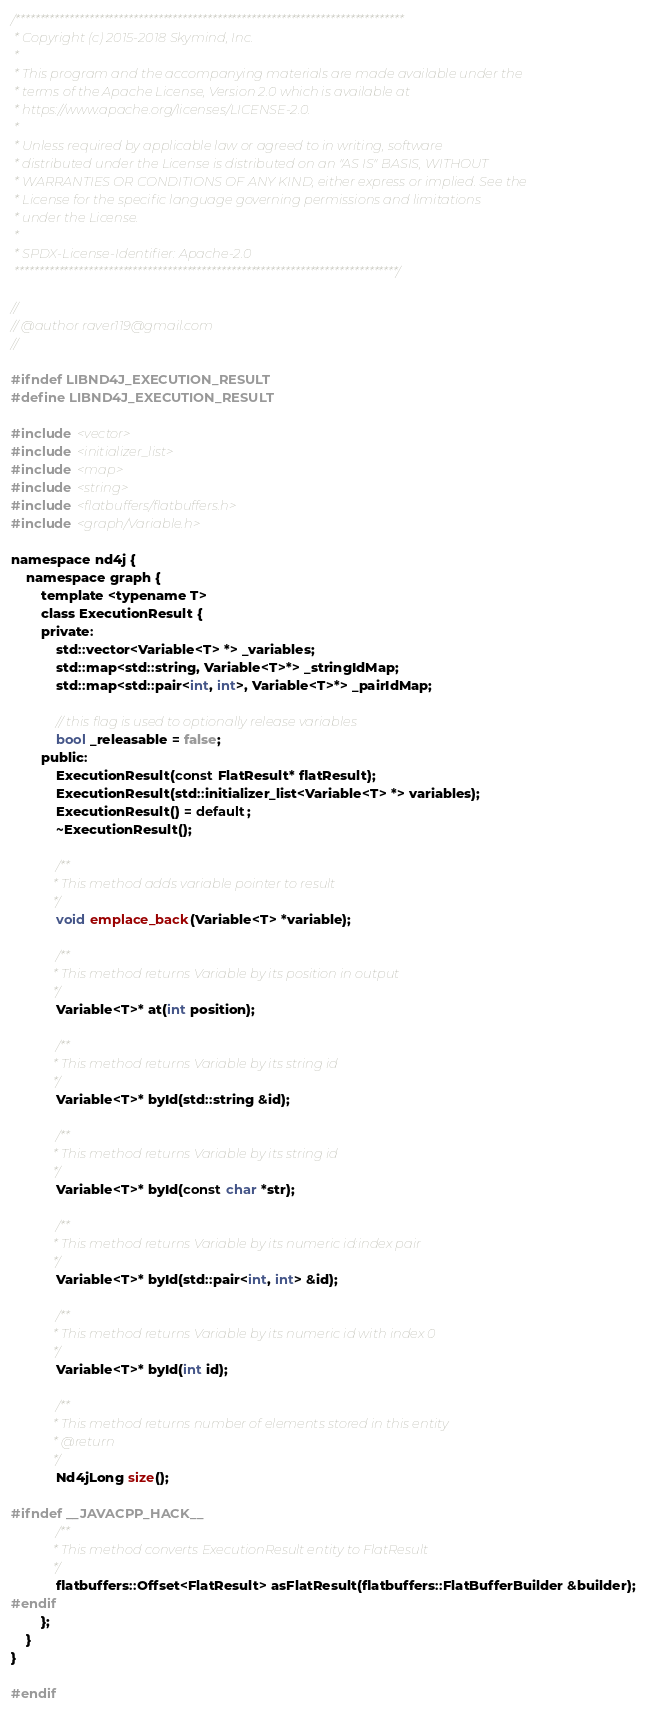<code> <loc_0><loc_0><loc_500><loc_500><_C_>/*******************************************************************************
 * Copyright (c) 2015-2018 Skymind, Inc.
 *
 * This program and the accompanying materials are made available under the
 * terms of the Apache License, Version 2.0 which is available at
 * https://www.apache.org/licenses/LICENSE-2.0.
 *
 * Unless required by applicable law or agreed to in writing, software
 * distributed under the License is distributed on an "AS IS" BASIS, WITHOUT
 * WARRANTIES OR CONDITIONS OF ANY KIND, either express or implied. See the
 * License for the specific language governing permissions and limitations
 * under the License.
 *
 * SPDX-License-Identifier: Apache-2.0
 ******************************************************************************/

//
// @author raver119@gmail.com
//

#ifndef LIBND4J_EXECUTION_RESULT
#define LIBND4J_EXECUTION_RESULT

#include <vector>
#include <initializer_list>
#include <map>
#include <string>
#include <flatbuffers/flatbuffers.h>
#include <graph/Variable.h>

namespace nd4j {
    namespace graph {
        template <typename T>
        class ExecutionResult {
        private:
            std::vector<Variable<T> *> _variables;
            std::map<std::string, Variable<T>*> _stringIdMap;
            std::map<std::pair<int, int>, Variable<T>*> _pairIdMap;

            // this flag is used to optionally release variables
            bool _releasable = false;
        public:
            ExecutionResult(const FlatResult* flatResult);
            ExecutionResult(std::initializer_list<Variable<T> *> variables);
            ExecutionResult() = default;
            ~ExecutionResult();

            /**
             * This method adds variable pointer to result
             */
            void emplace_back(Variable<T> *variable);

            /**
             * This method returns Variable by its position in output
             */
            Variable<T>* at(int position);

            /**
             * This method returns Variable by its string id
             */
            Variable<T>* byId(std::string &id);

            /**
             * This method returns Variable by its string id
             */
            Variable<T>* byId(const char *str);

            /**
             * This method returns Variable by its numeric id:index pair
             */
            Variable<T>* byId(std::pair<int, int> &id);

            /**
             * This method returns Variable by its numeric id with index 0
             */
            Variable<T>* byId(int id);

            /**
             * This method returns number of elements stored in this entity
             * @return
             */
            Nd4jLong size();

#ifndef __JAVACPP_HACK__
            /**
             * This method converts ExecutionResult entity to FlatResult
             */
            flatbuffers::Offset<FlatResult> asFlatResult(flatbuffers::FlatBufferBuilder &builder);
#endif
        };
    }
}

#endif</code> 